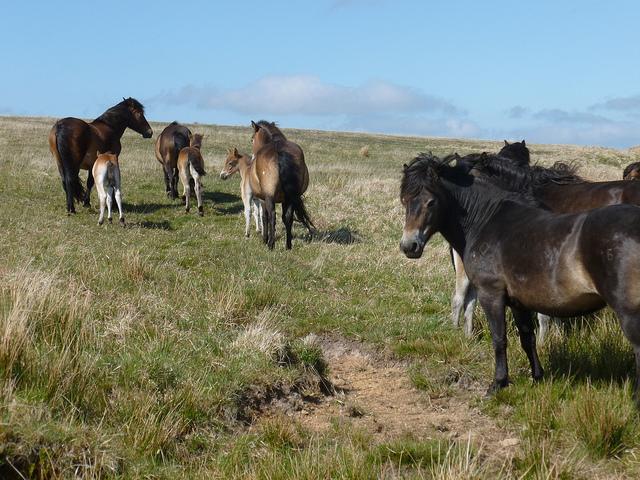Is this photo outdoors?
Keep it brief. Yes. What is in the far distance?
Concise answer only. Clouds. Is this animal free?
Quick response, please. Yes. What colors is the horse's coat?
Short answer required. Brown. What are these animals?
Keep it brief. Horses. How many animals are shown here?
Answer briefly. 9. 